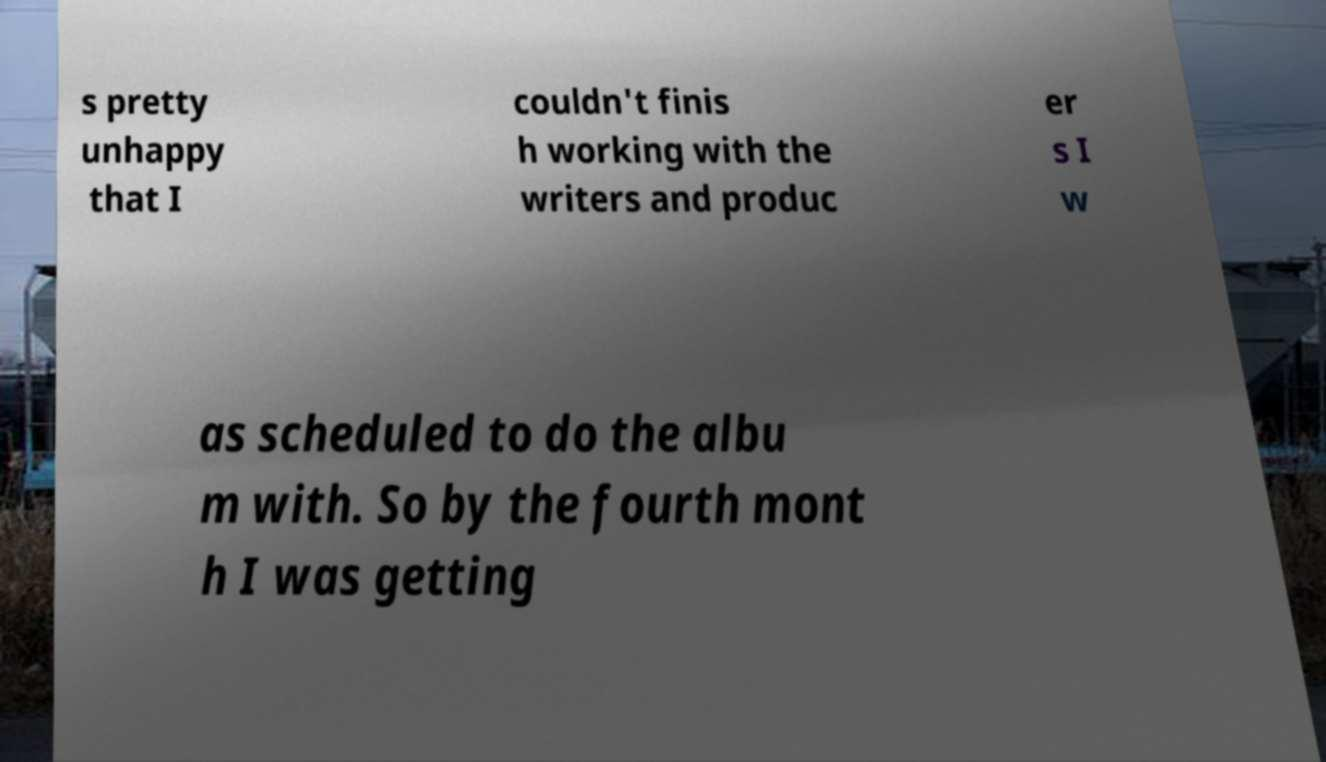I need the written content from this picture converted into text. Can you do that? s pretty unhappy that I couldn't finis h working with the writers and produc er s I w as scheduled to do the albu m with. So by the fourth mont h I was getting 